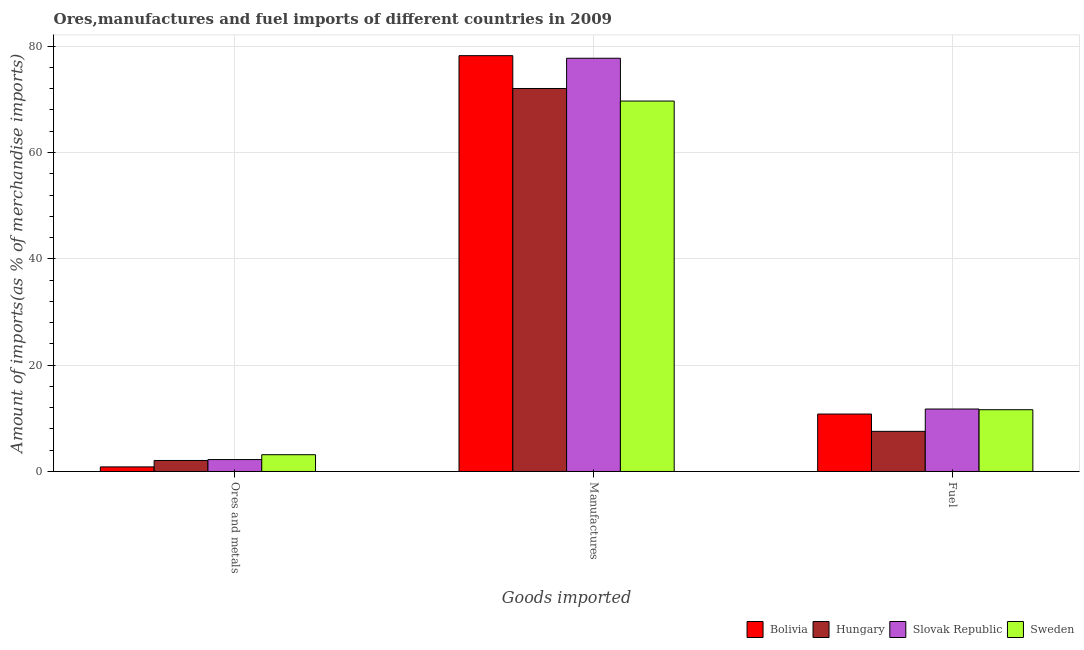Are the number of bars on each tick of the X-axis equal?
Offer a terse response. Yes. How many bars are there on the 1st tick from the left?
Offer a very short reply. 4. How many bars are there on the 2nd tick from the right?
Your answer should be compact. 4. What is the label of the 1st group of bars from the left?
Provide a succinct answer. Ores and metals. What is the percentage of manufactures imports in Sweden?
Your response must be concise. 69.67. Across all countries, what is the maximum percentage of fuel imports?
Make the answer very short. 11.75. Across all countries, what is the minimum percentage of fuel imports?
Offer a terse response. 7.55. In which country was the percentage of manufactures imports maximum?
Your answer should be compact. Bolivia. In which country was the percentage of fuel imports minimum?
Your response must be concise. Hungary. What is the total percentage of ores and metals imports in the graph?
Offer a terse response. 8.32. What is the difference between the percentage of manufactures imports in Hungary and that in Bolivia?
Your response must be concise. -6.17. What is the difference between the percentage of manufactures imports in Hungary and the percentage of ores and metals imports in Slovak Republic?
Make the answer very short. 69.8. What is the average percentage of ores and metals imports per country?
Give a very brief answer. 2.08. What is the difference between the percentage of ores and metals imports and percentage of manufactures imports in Hungary?
Give a very brief answer. -69.97. What is the ratio of the percentage of fuel imports in Slovak Republic to that in Bolivia?
Offer a terse response. 1.09. Is the difference between the percentage of ores and metals imports in Sweden and Hungary greater than the difference between the percentage of manufactures imports in Sweden and Hungary?
Your response must be concise. Yes. What is the difference between the highest and the second highest percentage of ores and metals imports?
Offer a terse response. 0.91. What is the difference between the highest and the lowest percentage of fuel imports?
Give a very brief answer. 4.2. What does the 3rd bar from the left in Manufactures represents?
Give a very brief answer. Slovak Republic. What does the 2nd bar from the right in Manufactures represents?
Make the answer very short. Slovak Republic. Are all the bars in the graph horizontal?
Keep it short and to the point. No. What is the difference between two consecutive major ticks on the Y-axis?
Keep it short and to the point. 20. Are the values on the major ticks of Y-axis written in scientific E-notation?
Make the answer very short. No. Where does the legend appear in the graph?
Ensure brevity in your answer.  Bottom right. How many legend labels are there?
Give a very brief answer. 4. How are the legend labels stacked?
Your answer should be very brief. Horizontal. What is the title of the graph?
Offer a very short reply. Ores,manufactures and fuel imports of different countries in 2009. Does "Tunisia" appear as one of the legend labels in the graph?
Your response must be concise. No. What is the label or title of the X-axis?
Ensure brevity in your answer.  Goods imported. What is the label or title of the Y-axis?
Ensure brevity in your answer.  Amount of imports(as % of merchandise imports). What is the Amount of imports(as % of merchandise imports) of Bolivia in Ores and metals?
Offer a terse response. 0.86. What is the Amount of imports(as % of merchandise imports) in Hungary in Ores and metals?
Provide a short and direct response. 2.07. What is the Amount of imports(as % of merchandise imports) of Slovak Republic in Ores and metals?
Offer a terse response. 2.24. What is the Amount of imports(as % of merchandise imports) in Sweden in Ores and metals?
Keep it short and to the point. 3.15. What is the Amount of imports(as % of merchandise imports) of Bolivia in Manufactures?
Your answer should be compact. 78.21. What is the Amount of imports(as % of merchandise imports) in Hungary in Manufactures?
Your answer should be very brief. 72.04. What is the Amount of imports(as % of merchandise imports) of Slovak Republic in Manufactures?
Keep it short and to the point. 77.72. What is the Amount of imports(as % of merchandise imports) of Sweden in Manufactures?
Give a very brief answer. 69.67. What is the Amount of imports(as % of merchandise imports) in Bolivia in Fuel?
Make the answer very short. 10.8. What is the Amount of imports(as % of merchandise imports) of Hungary in Fuel?
Offer a very short reply. 7.55. What is the Amount of imports(as % of merchandise imports) of Slovak Republic in Fuel?
Keep it short and to the point. 11.75. What is the Amount of imports(as % of merchandise imports) in Sweden in Fuel?
Give a very brief answer. 11.62. Across all Goods imported, what is the maximum Amount of imports(as % of merchandise imports) in Bolivia?
Offer a terse response. 78.21. Across all Goods imported, what is the maximum Amount of imports(as % of merchandise imports) in Hungary?
Ensure brevity in your answer.  72.04. Across all Goods imported, what is the maximum Amount of imports(as % of merchandise imports) of Slovak Republic?
Give a very brief answer. 77.72. Across all Goods imported, what is the maximum Amount of imports(as % of merchandise imports) of Sweden?
Ensure brevity in your answer.  69.67. Across all Goods imported, what is the minimum Amount of imports(as % of merchandise imports) of Bolivia?
Offer a terse response. 0.86. Across all Goods imported, what is the minimum Amount of imports(as % of merchandise imports) of Hungary?
Your answer should be very brief. 2.07. Across all Goods imported, what is the minimum Amount of imports(as % of merchandise imports) in Slovak Republic?
Offer a very short reply. 2.24. Across all Goods imported, what is the minimum Amount of imports(as % of merchandise imports) of Sweden?
Your answer should be compact. 3.15. What is the total Amount of imports(as % of merchandise imports) of Bolivia in the graph?
Provide a short and direct response. 89.87. What is the total Amount of imports(as % of merchandise imports) of Hungary in the graph?
Give a very brief answer. 81.65. What is the total Amount of imports(as % of merchandise imports) of Slovak Republic in the graph?
Offer a terse response. 91.71. What is the total Amount of imports(as % of merchandise imports) of Sweden in the graph?
Your answer should be very brief. 84.44. What is the difference between the Amount of imports(as % of merchandise imports) of Bolivia in Ores and metals and that in Manufactures?
Provide a succinct answer. -77.35. What is the difference between the Amount of imports(as % of merchandise imports) of Hungary in Ores and metals and that in Manufactures?
Make the answer very short. -69.97. What is the difference between the Amount of imports(as % of merchandise imports) in Slovak Republic in Ores and metals and that in Manufactures?
Make the answer very short. -75.48. What is the difference between the Amount of imports(as % of merchandise imports) of Sweden in Ores and metals and that in Manufactures?
Make the answer very short. -66.52. What is the difference between the Amount of imports(as % of merchandise imports) in Bolivia in Ores and metals and that in Fuel?
Your answer should be compact. -9.94. What is the difference between the Amount of imports(as % of merchandise imports) in Hungary in Ores and metals and that in Fuel?
Make the answer very short. -5.48. What is the difference between the Amount of imports(as % of merchandise imports) of Slovak Republic in Ores and metals and that in Fuel?
Provide a short and direct response. -9.51. What is the difference between the Amount of imports(as % of merchandise imports) of Sweden in Ores and metals and that in Fuel?
Your response must be concise. -8.46. What is the difference between the Amount of imports(as % of merchandise imports) in Bolivia in Manufactures and that in Fuel?
Provide a short and direct response. 67.41. What is the difference between the Amount of imports(as % of merchandise imports) in Hungary in Manufactures and that in Fuel?
Provide a succinct answer. 64.49. What is the difference between the Amount of imports(as % of merchandise imports) of Slovak Republic in Manufactures and that in Fuel?
Provide a succinct answer. 65.97. What is the difference between the Amount of imports(as % of merchandise imports) in Sweden in Manufactures and that in Fuel?
Give a very brief answer. 58.05. What is the difference between the Amount of imports(as % of merchandise imports) of Bolivia in Ores and metals and the Amount of imports(as % of merchandise imports) of Hungary in Manufactures?
Your answer should be compact. -71.17. What is the difference between the Amount of imports(as % of merchandise imports) of Bolivia in Ores and metals and the Amount of imports(as % of merchandise imports) of Slovak Republic in Manufactures?
Provide a succinct answer. -76.86. What is the difference between the Amount of imports(as % of merchandise imports) of Bolivia in Ores and metals and the Amount of imports(as % of merchandise imports) of Sweden in Manufactures?
Your response must be concise. -68.81. What is the difference between the Amount of imports(as % of merchandise imports) in Hungary in Ores and metals and the Amount of imports(as % of merchandise imports) in Slovak Republic in Manufactures?
Your response must be concise. -75.65. What is the difference between the Amount of imports(as % of merchandise imports) of Hungary in Ores and metals and the Amount of imports(as % of merchandise imports) of Sweden in Manufactures?
Your response must be concise. -67.6. What is the difference between the Amount of imports(as % of merchandise imports) of Slovak Republic in Ores and metals and the Amount of imports(as % of merchandise imports) of Sweden in Manufactures?
Keep it short and to the point. -67.43. What is the difference between the Amount of imports(as % of merchandise imports) in Bolivia in Ores and metals and the Amount of imports(as % of merchandise imports) in Hungary in Fuel?
Your answer should be compact. -6.69. What is the difference between the Amount of imports(as % of merchandise imports) in Bolivia in Ores and metals and the Amount of imports(as % of merchandise imports) in Slovak Republic in Fuel?
Your answer should be very brief. -10.89. What is the difference between the Amount of imports(as % of merchandise imports) of Bolivia in Ores and metals and the Amount of imports(as % of merchandise imports) of Sweden in Fuel?
Offer a terse response. -10.76. What is the difference between the Amount of imports(as % of merchandise imports) in Hungary in Ores and metals and the Amount of imports(as % of merchandise imports) in Slovak Republic in Fuel?
Give a very brief answer. -9.68. What is the difference between the Amount of imports(as % of merchandise imports) of Hungary in Ores and metals and the Amount of imports(as % of merchandise imports) of Sweden in Fuel?
Your answer should be compact. -9.55. What is the difference between the Amount of imports(as % of merchandise imports) in Slovak Republic in Ores and metals and the Amount of imports(as % of merchandise imports) in Sweden in Fuel?
Keep it short and to the point. -9.38. What is the difference between the Amount of imports(as % of merchandise imports) of Bolivia in Manufactures and the Amount of imports(as % of merchandise imports) of Hungary in Fuel?
Your answer should be very brief. 70.66. What is the difference between the Amount of imports(as % of merchandise imports) in Bolivia in Manufactures and the Amount of imports(as % of merchandise imports) in Slovak Republic in Fuel?
Offer a terse response. 66.46. What is the difference between the Amount of imports(as % of merchandise imports) of Bolivia in Manufactures and the Amount of imports(as % of merchandise imports) of Sweden in Fuel?
Make the answer very short. 66.59. What is the difference between the Amount of imports(as % of merchandise imports) in Hungary in Manufactures and the Amount of imports(as % of merchandise imports) in Slovak Republic in Fuel?
Provide a short and direct response. 60.29. What is the difference between the Amount of imports(as % of merchandise imports) of Hungary in Manufactures and the Amount of imports(as % of merchandise imports) of Sweden in Fuel?
Your answer should be compact. 60.42. What is the difference between the Amount of imports(as % of merchandise imports) of Slovak Republic in Manufactures and the Amount of imports(as % of merchandise imports) of Sweden in Fuel?
Your response must be concise. 66.1. What is the average Amount of imports(as % of merchandise imports) in Bolivia per Goods imported?
Keep it short and to the point. 29.96. What is the average Amount of imports(as % of merchandise imports) in Hungary per Goods imported?
Give a very brief answer. 27.22. What is the average Amount of imports(as % of merchandise imports) of Slovak Republic per Goods imported?
Offer a terse response. 30.57. What is the average Amount of imports(as % of merchandise imports) of Sweden per Goods imported?
Offer a very short reply. 28.15. What is the difference between the Amount of imports(as % of merchandise imports) of Bolivia and Amount of imports(as % of merchandise imports) of Hungary in Ores and metals?
Make the answer very short. -1.21. What is the difference between the Amount of imports(as % of merchandise imports) of Bolivia and Amount of imports(as % of merchandise imports) of Slovak Republic in Ores and metals?
Make the answer very short. -1.38. What is the difference between the Amount of imports(as % of merchandise imports) in Bolivia and Amount of imports(as % of merchandise imports) in Sweden in Ores and metals?
Give a very brief answer. -2.29. What is the difference between the Amount of imports(as % of merchandise imports) of Hungary and Amount of imports(as % of merchandise imports) of Slovak Republic in Ores and metals?
Your answer should be very brief. -0.17. What is the difference between the Amount of imports(as % of merchandise imports) in Hungary and Amount of imports(as % of merchandise imports) in Sweden in Ores and metals?
Provide a succinct answer. -1.09. What is the difference between the Amount of imports(as % of merchandise imports) of Slovak Republic and Amount of imports(as % of merchandise imports) of Sweden in Ores and metals?
Provide a short and direct response. -0.91. What is the difference between the Amount of imports(as % of merchandise imports) in Bolivia and Amount of imports(as % of merchandise imports) in Hungary in Manufactures?
Keep it short and to the point. 6.17. What is the difference between the Amount of imports(as % of merchandise imports) in Bolivia and Amount of imports(as % of merchandise imports) in Slovak Republic in Manufactures?
Offer a terse response. 0.49. What is the difference between the Amount of imports(as % of merchandise imports) of Bolivia and Amount of imports(as % of merchandise imports) of Sweden in Manufactures?
Make the answer very short. 8.54. What is the difference between the Amount of imports(as % of merchandise imports) in Hungary and Amount of imports(as % of merchandise imports) in Slovak Republic in Manufactures?
Provide a short and direct response. -5.69. What is the difference between the Amount of imports(as % of merchandise imports) in Hungary and Amount of imports(as % of merchandise imports) in Sweden in Manufactures?
Offer a terse response. 2.36. What is the difference between the Amount of imports(as % of merchandise imports) of Slovak Republic and Amount of imports(as % of merchandise imports) of Sweden in Manufactures?
Keep it short and to the point. 8.05. What is the difference between the Amount of imports(as % of merchandise imports) of Bolivia and Amount of imports(as % of merchandise imports) of Hungary in Fuel?
Give a very brief answer. 3.25. What is the difference between the Amount of imports(as % of merchandise imports) in Bolivia and Amount of imports(as % of merchandise imports) in Slovak Republic in Fuel?
Provide a succinct answer. -0.95. What is the difference between the Amount of imports(as % of merchandise imports) in Bolivia and Amount of imports(as % of merchandise imports) in Sweden in Fuel?
Make the answer very short. -0.82. What is the difference between the Amount of imports(as % of merchandise imports) in Hungary and Amount of imports(as % of merchandise imports) in Slovak Republic in Fuel?
Provide a short and direct response. -4.2. What is the difference between the Amount of imports(as % of merchandise imports) in Hungary and Amount of imports(as % of merchandise imports) in Sweden in Fuel?
Your answer should be compact. -4.07. What is the difference between the Amount of imports(as % of merchandise imports) in Slovak Republic and Amount of imports(as % of merchandise imports) in Sweden in Fuel?
Offer a very short reply. 0.13. What is the ratio of the Amount of imports(as % of merchandise imports) in Bolivia in Ores and metals to that in Manufactures?
Offer a very short reply. 0.01. What is the ratio of the Amount of imports(as % of merchandise imports) in Hungary in Ores and metals to that in Manufactures?
Your answer should be compact. 0.03. What is the ratio of the Amount of imports(as % of merchandise imports) of Slovak Republic in Ores and metals to that in Manufactures?
Make the answer very short. 0.03. What is the ratio of the Amount of imports(as % of merchandise imports) in Sweden in Ores and metals to that in Manufactures?
Ensure brevity in your answer.  0.05. What is the ratio of the Amount of imports(as % of merchandise imports) of Bolivia in Ores and metals to that in Fuel?
Your response must be concise. 0.08. What is the ratio of the Amount of imports(as % of merchandise imports) in Hungary in Ores and metals to that in Fuel?
Your answer should be compact. 0.27. What is the ratio of the Amount of imports(as % of merchandise imports) of Slovak Republic in Ores and metals to that in Fuel?
Your answer should be compact. 0.19. What is the ratio of the Amount of imports(as % of merchandise imports) in Sweden in Ores and metals to that in Fuel?
Your response must be concise. 0.27. What is the ratio of the Amount of imports(as % of merchandise imports) of Bolivia in Manufactures to that in Fuel?
Make the answer very short. 7.24. What is the ratio of the Amount of imports(as % of merchandise imports) in Hungary in Manufactures to that in Fuel?
Provide a succinct answer. 9.54. What is the ratio of the Amount of imports(as % of merchandise imports) in Slovak Republic in Manufactures to that in Fuel?
Make the answer very short. 6.62. What is the ratio of the Amount of imports(as % of merchandise imports) of Sweden in Manufactures to that in Fuel?
Ensure brevity in your answer.  6. What is the difference between the highest and the second highest Amount of imports(as % of merchandise imports) in Bolivia?
Make the answer very short. 67.41. What is the difference between the highest and the second highest Amount of imports(as % of merchandise imports) in Hungary?
Give a very brief answer. 64.49. What is the difference between the highest and the second highest Amount of imports(as % of merchandise imports) of Slovak Republic?
Your answer should be compact. 65.97. What is the difference between the highest and the second highest Amount of imports(as % of merchandise imports) in Sweden?
Provide a short and direct response. 58.05. What is the difference between the highest and the lowest Amount of imports(as % of merchandise imports) of Bolivia?
Your answer should be very brief. 77.35. What is the difference between the highest and the lowest Amount of imports(as % of merchandise imports) of Hungary?
Your answer should be very brief. 69.97. What is the difference between the highest and the lowest Amount of imports(as % of merchandise imports) in Slovak Republic?
Give a very brief answer. 75.48. What is the difference between the highest and the lowest Amount of imports(as % of merchandise imports) of Sweden?
Give a very brief answer. 66.52. 